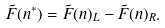Convert formula to latex. <formula><loc_0><loc_0><loc_500><loc_500>\tilde { F } ( n ^ { * } ) = \tilde { F } ( n ) _ { L } - \tilde { F } ( n ) _ { R } .</formula> 